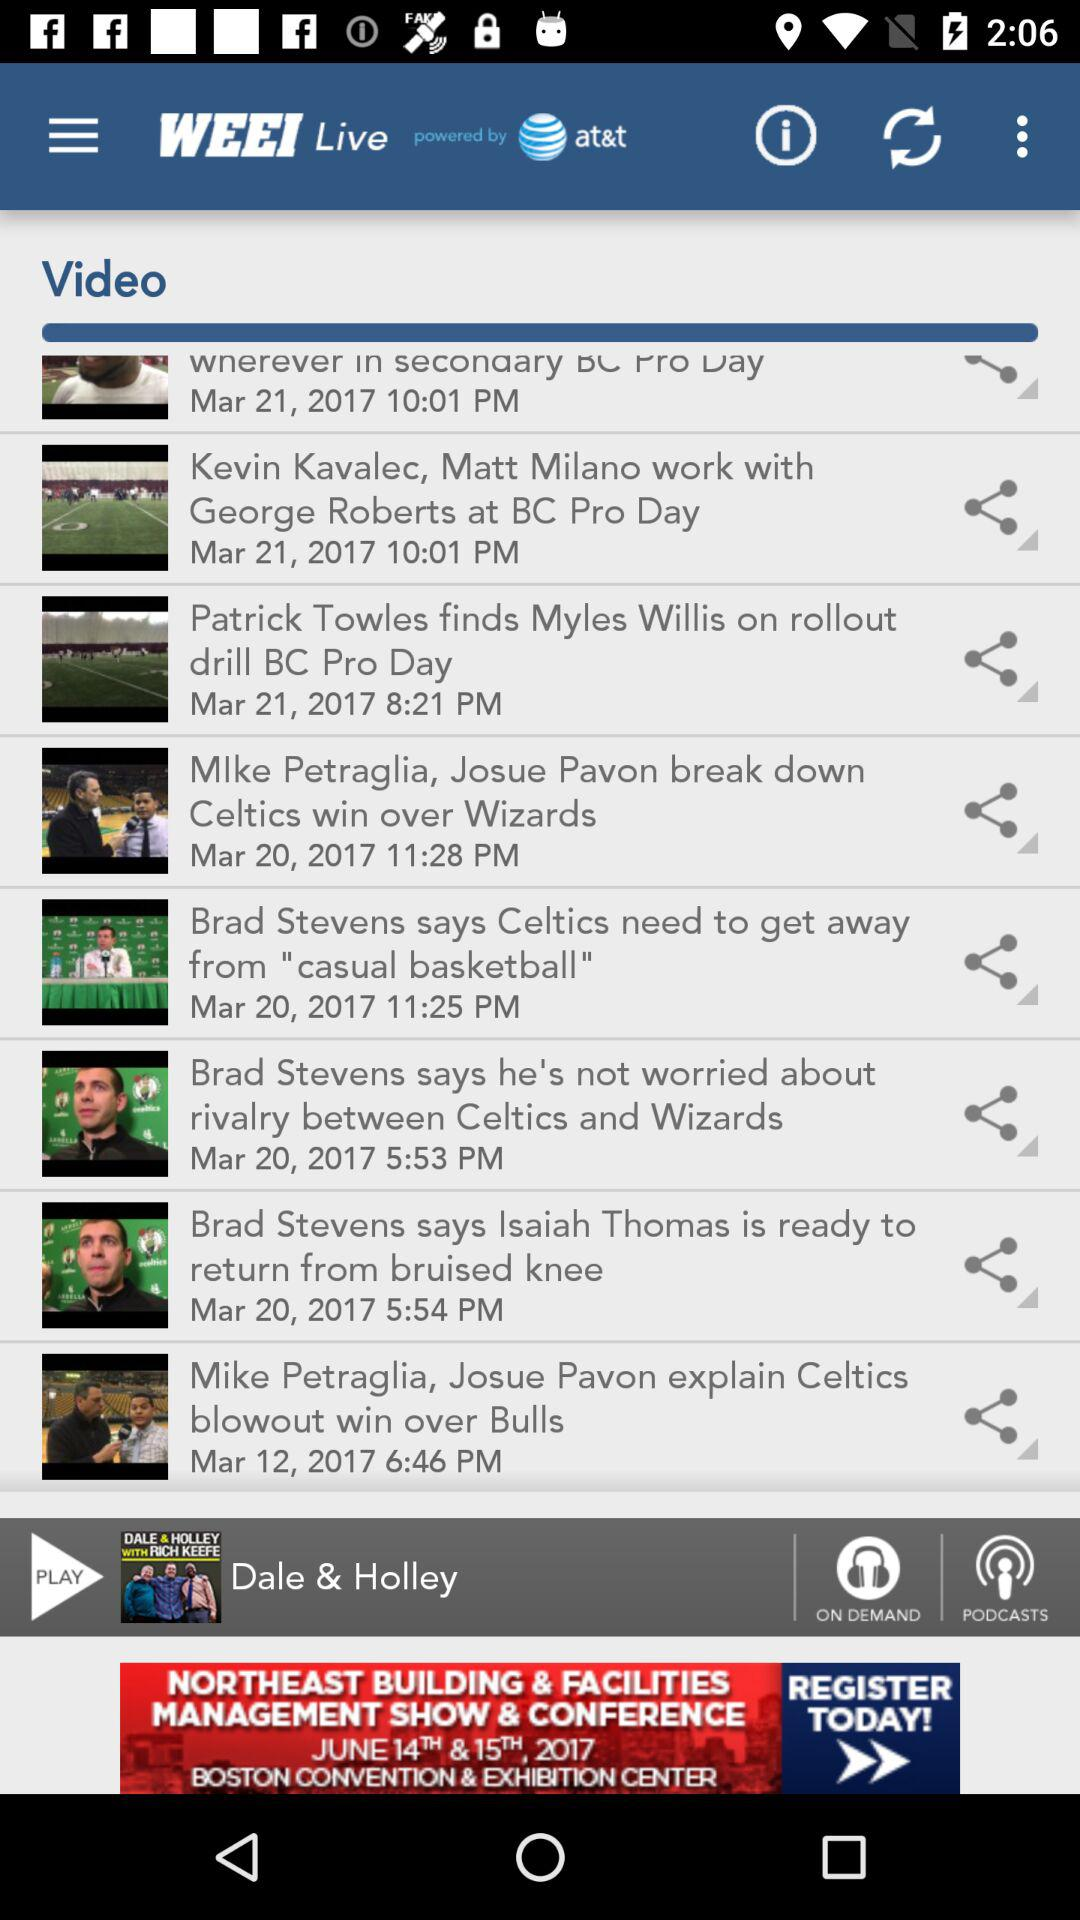What is the name of the application? The name of the application is "WEEI Live". 